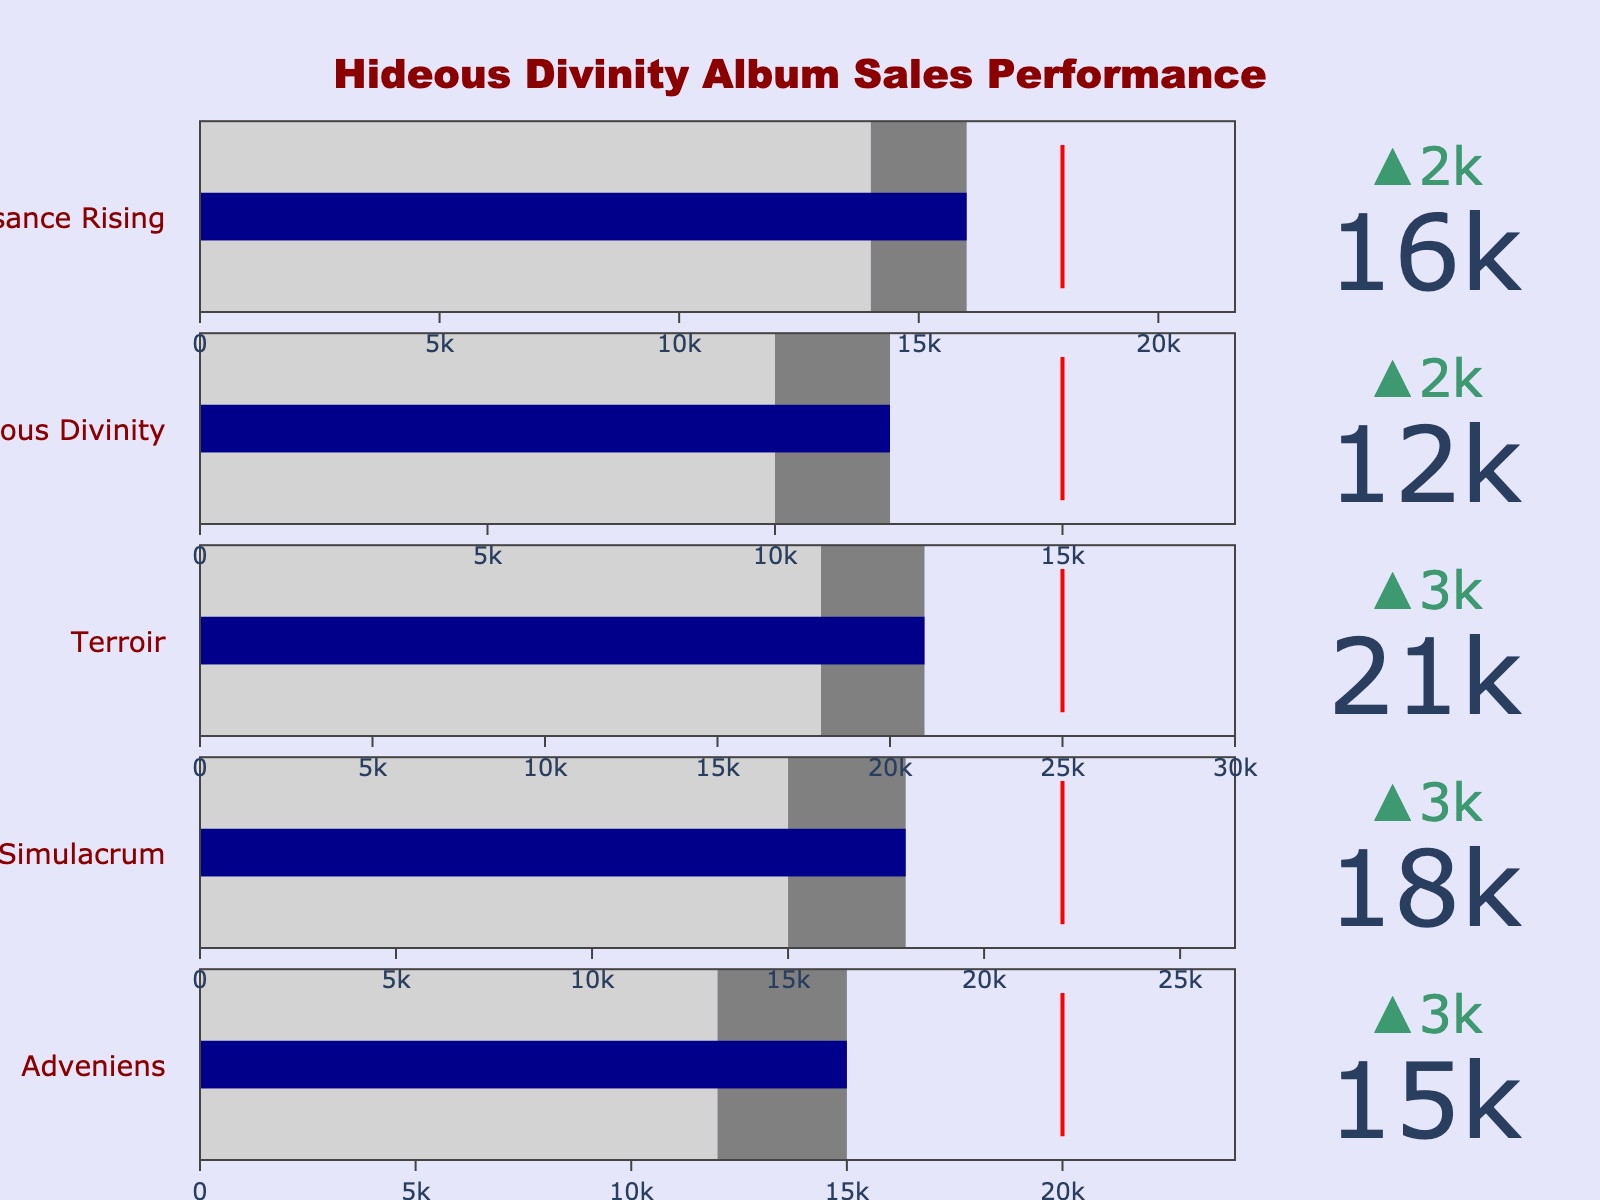What's the title of the plot? The title is prominently displayed at the top of the chart. It reads "Hideous Divinity Album Sales Performance".
Answer: Hideous Divinity Album Sales Performance How did "Adveniens" perform compared to its target? The actual sales for "Adveniens" are 15,000, and the target sales are 20,000. The actual sales fall short of the target.
Answer: Below Target What is the difference between the actual and target sales for "Simulacrum"? The target sales for "Simulacrum" are 22,000, and the actual sales are 18,000. The difference is calculated as 22,000 - 18,000 = 4,000.
Answer: 4,000 Did "Obeisance Rising" exceed the previous year's sales? The actual sales for "Obeisance Rising" are 16,000, and the previous year's sales are 14,000. Since 16,000 is greater than 14,000, it did exceed the previous year's sales.
Answer: Yes Which album had the highest actual sales? The chart shows the actual sales for each album. "Terroir" has the highest actual sales with a value of 21,000.
Answer: Terroir Which album had the smallest improvement in sales from the previous year? Calculate the difference between actual and previous year sales for each album. "Hideous Divinity" has an increase of 2,000 (12,000 - 10,000), which is the smallest improvement.
Answer: Hideous Divinity How did "Terroir" perform in comparison to its target and previous year sales? The actual sales for "Terroir" are 21,000, the target sales are 25,000, and the previous year's sales are 18,000. It did not meet the target as 21,000 is less than 25,000 but improved from last year's performance as 21,000 is greater than 18,000.
Answer: Not met, improved What is the total actual sales for all albums combined? Sum the actual sales for all albums: 15,000 + 18,000 + 21,000 + 12,000 + 16,000 = 82,000.
Answer: 82,000 By how much did the actual sales for "Hideous Divinity" fall short of the target sales? The actual sales for "Hideous Divinity" are 12,000, and the target sales are 15,000. The shortfall is calculated as 15,000 - 12,000 = 3,000.
Answer: 3,000 